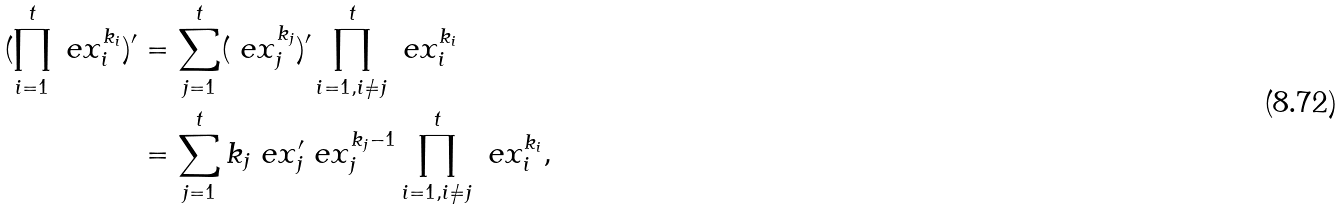<formula> <loc_0><loc_0><loc_500><loc_500>( \prod ^ { t } _ { i = 1 } \ e x ^ { k _ { i } } _ { i } ) ^ { \prime } & = \sum ^ { t } _ { j = 1 } ( \ e x ^ { k _ { j } } _ { j } ) ^ { \prime } \prod ^ { t } _ { i = 1 , i \neq j } \ e x ^ { k _ { i } } _ { i } \\ & = \sum ^ { t } _ { j = 1 } k _ { j } \ e x ^ { \prime } _ { j } \ e x ^ { k _ { j } - 1 } _ { j } \prod ^ { t } _ { i = 1 , i \neq j } \ e x ^ { k _ { i } } _ { i } ,</formula> 